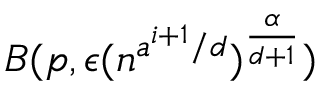Convert formula to latex. <formula><loc_0><loc_0><loc_500><loc_500>B ( p , \epsilon ( n ^ { a ^ { i + 1 } / d } ) ^ { \frac { \alpha } { d + 1 } } )</formula> 